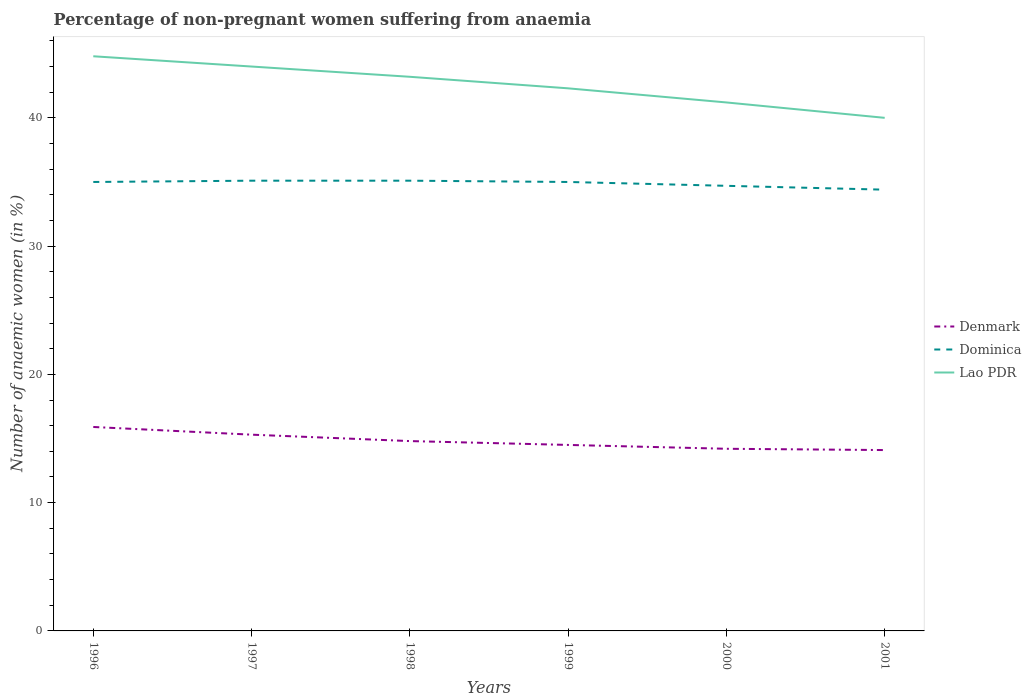Does the line corresponding to Denmark intersect with the line corresponding to Lao PDR?
Provide a succinct answer. No. What is the total percentage of non-pregnant women suffering from anaemia in Dominica in the graph?
Your response must be concise. 0.6. What is the difference between the highest and the second highest percentage of non-pregnant women suffering from anaemia in Dominica?
Make the answer very short. 0.7. How many lines are there?
Provide a short and direct response. 3. How many years are there in the graph?
Keep it short and to the point. 6. What is the difference between two consecutive major ticks on the Y-axis?
Offer a terse response. 10. Does the graph contain grids?
Make the answer very short. No. How many legend labels are there?
Give a very brief answer. 3. How are the legend labels stacked?
Keep it short and to the point. Vertical. What is the title of the graph?
Your answer should be compact. Percentage of non-pregnant women suffering from anaemia. Does "Germany" appear as one of the legend labels in the graph?
Keep it short and to the point. No. What is the label or title of the X-axis?
Provide a short and direct response. Years. What is the label or title of the Y-axis?
Your answer should be very brief. Number of anaemic women (in %). What is the Number of anaemic women (in %) in Lao PDR in 1996?
Offer a very short reply. 44.8. What is the Number of anaemic women (in %) in Denmark in 1997?
Provide a short and direct response. 15.3. What is the Number of anaemic women (in %) in Dominica in 1997?
Your answer should be compact. 35.1. What is the Number of anaemic women (in %) of Lao PDR in 1997?
Provide a succinct answer. 44. What is the Number of anaemic women (in %) in Dominica in 1998?
Offer a terse response. 35.1. What is the Number of anaemic women (in %) in Lao PDR in 1998?
Ensure brevity in your answer.  43.2. What is the Number of anaemic women (in %) in Denmark in 1999?
Your response must be concise. 14.5. What is the Number of anaemic women (in %) in Lao PDR in 1999?
Offer a very short reply. 42.3. What is the Number of anaemic women (in %) of Dominica in 2000?
Ensure brevity in your answer.  34.7. What is the Number of anaemic women (in %) in Lao PDR in 2000?
Provide a succinct answer. 41.2. What is the Number of anaemic women (in %) in Denmark in 2001?
Your answer should be compact. 14.1. What is the Number of anaemic women (in %) in Dominica in 2001?
Provide a short and direct response. 34.4. Across all years, what is the maximum Number of anaemic women (in %) in Dominica?
Provide a short and direct response. 35.1. Across all years, what is the maximum Number of anaemic women (in %) of Lao PDR?
Offer a terse response. 44.8. Across all years, what is the minimum Number of anaemic women (in %) of Dominica?
Offer a terse response. 34.4. Across all years, what is the minimum Number of anaemic women (in %) of Lao PDR?
Your answer should be compact. 40. What is the total Number of anaemic women (in %) of Denmark in the graph?
Provide a succinct answer. 88.8. What is the total Number of anaemic women (in %) of Dominica in the graph?
Your answer should be compact. 209.3. What is the total Number of anaemic women (in %) of Lao PDR in the graph?
Offer a very short reply. 255.5. What is the difference between the Number of anaemic women (in %) of Denmark in 1996 and that in 1998?
Give a very brief answer. 1.1. What is the difference between the Number of anaemic women (in %) of Dominica in 1996 and that in 1998?
Offer a very short reply. -0.1. What is the difference between the Number of anaemic women (in %) in Lao PDR in 1996 and that in 1998?
Offer a very short reply. 1.6. What is the difference between the Number of anaemic women (in %) in Denmark in 1996 and that in 1999?
Keep it short and to the point. 1.4. What is the difference between the Number of anaemic women (in %) in Dominica in 1996 and that in 1999?
Make the answer very short. 0. What is the difference between the Number of anaemic women (in %) in Dominica in 1996 and that in 2000?
Ensure brevity in your answer.  0.3. What is the difference between the Number of anaemic women (in %) of Lao PDR in 1996 and that in 2000?
Your response must be concise. 3.6. What is the difference between the Number of anaemic women (in %) of Denmark in 1996 and that in 2001?
Your response must be concise. 1.8. What is the difference between the Number of anaemic women (in %) of Lao PDR in 1996 and that in 2001?
Offer a terse response. 4.8. What is the difference between the Number of anaemic women (in %) in Denmark in 1997 and that in 1999?
Make the answer very short. 0.8. What is the difference between the Number of anaemic women (in %) in Denmark in 1997 and that in 2000?
Provide a succinct answer. 1.1. What is the difference between the Number of anaemic women (in %) of Dominica in 1997 and that in 2000?
Your answer should be very brief. 0.4. What is the difference between the Number of anaemic women (in %) in Lao PDR in 1997 and that in 2000?
Offer a terse response. 2.8. What is the difference between the Number of anaemic women (in %) of Lao PDR in 1997 and that in 2001?
Provide a short and direct response. 4. What is the difference between the Number of anaemic women (in %) in Denmark in 1998 and that in 1999?
Provide a succinct answer. 0.3. What is the difference between the Number of anaemic women (in %) in Dominica in 1998 and that in 2000?
Make the answer very short. 0.4. What is the difference between the Number of anaemic women (in %) of Lao PDR in 1998 and that in 2000?
Give a very brief answer. 2. What is the difference between the Number of anaemic women (in %) of Denmark in 1998 and that in 2001?
Offer a terse response. 0.7. What is the difference between the Number of anaemic women (in %) in Dominica in 1998 and that in 2001?
Make the answer very short. 0.7. What is the difference between the Number of anaemic women (in %) of Denmark in 1999 and that in 2000?
Keep it short and to the point. 0.3. What is the difference between the Number of anaemic women (in %) in Dominica in 1999 and that in 2000?
Give a very brief answer. 0.3. What is the difference between the Number of anaemic women (in %) of Denmark in 1999 and that in 2001?
Offer a terse response. 0.4. What is the difference between the Number of anaemic women (in %) of Dominica in 1999 and that in 2001?
Keep it short and to the point. 0.6. What is the difference between the Number of anaemic women (in %) in Denmark in 1996 and the Number of anaemic women (in %) in Dominica in 1997?
Make the answer very short. -19.2. What is the difference between the Number of anaemic women (in %) in Denmark in 1996 and the Number of anaemic women (in %) in Lao PDR in 1997?
Ensure brevity in your answer.  -28.1. What is the difference between the Number of anaemic women (in %) in Dominica in 1996 and the Number of anaemic women (in %) in Lao PDR in 1997?
Your answer should be compact. -9. What is the difference between the Number of anaemic women (in %) in Denmark in 1996 and the Number of anaemic women (in %) in Dominica in 1998?
Your response must be concise. -19.2. What is the difference between the Number of anaemic women (in %) in Denmark in 1996 and the Number of anaemic women (in %) in Lao PDR in 1998?
Your response must be concise. -27.3. What is the difference between the Number of anaemic women (in %) in Denmark in 1996 and the Number of anaemic women (in %) in Dominica in 1999?
Give a very brief answer. -19.1. What is the difference between the Number of anaemic women (in %) in Denmark in 1996 and the Number of anaemic women (in %) in Lao PDR in 1999?
Provide a short and direct response. -26.4. What is the difference between the Number of anaemic women (in %) of Dominica in 1996 and the Number of anaemic women (in %) of Lao PDR in 1999?
Provide a short and direct response. -7.3. What is the difference between the Number of anaemic women (in %) in Denmark in 1996 and the Number of anaemic women (in %) in Dominica in 2000?
Your answer should be compact. -18.8. What is the difference between the Number of anaemic women (in %) in Denmark in 1996 and the Number of anaemic women (in %) in Lao PDR in 2000?
Keep it short and to the point. -25.3. What is the difference between the Number of anaemic women (in %) of Denmark in 1996 and the Number of anaemic women (in %) of Dominica in 2001?
Keep it short and to the point. -18.5. What is the difference between the Number of anaemic women (in %) of Denmark in 1996 and the Number of anaemic women (in %) of Lao PDR in 2001?
Your answer should be compact. -24.1. What is the difference between the Number of anaemic women (in %) in Denmark in 1997 and the Number of anaemic women (in %) in Dominica in 1998?
Keep it short and to the point. -19.8. What is the difference between the Number of anaemic women (in %) of Denmark in 1997 and the Number of anaemic women (in %) of Lao PDR in 1998?
Keep it short and to the point. -27.9. What is the difference between the Number of anaemic women (in %) in Dominica in 1997 and the Number of anaemic women (in %) in Lao PDR in 1998?
Make the answer very short. -8.1. What is the difference between the Number of anaemic women (in %) in Denmark in 1997 and the Number of anaemic women (in %) in Dominica in 1999?
Provide a succinct answer. -19.7. What is the difference between the Number of anaemic women (in %) of Denmark in 1997 and the Number of anaemic women (in %) of Dominica in 2000?
Provide a short and direct response. -19.4. What is the difference between the Number of anaemic women (in %) in Denmark in 1997 and the Number of anaemic women (in %) in Lao PDR in 2000?
Offer a terse response. -25.9. What is the difference between the Number of anaemic women (in %) in Denmark in 1997 and the Number of anaemic women (in %) in Dominica in 2001?
Offer a very short reply. -19.1. What is the difference between the Number of anaemic women (in %) in Denmark in 1997 and the Number of anaemic women (in %) in Lao PDR in 2001?
Your answer should be very brief. -24.7. What is the difference between the Number of anaemic women (in %) in Denmark in 1998 and the Number of anaemic women (in %) in Dominica in 1999?
Offer a terse response. -20.2. What is the difference between the Number of anaemic women (in %) in Denmark in 1998 and the Number of anaemic women (in %) in Lao PDR in 1999?
Ensure brevity in your answer.  -27.5. What is the difference between the Number of anaemic women (in %) of Dominica in 1998 and the Number of anaemic women (in %) of Lao PDR in 1999?
Your answer should be compact. -7.2. What is the difference between the Number of anaemic women (in %) of Denmark in 1998 and the Number of anaemic women (in %) of Dominica in 2000?
Keep it short and to the point. -19.9. What is the difference between the Number of anaemic women (in %) of Denmark in 1998 and the Number of anaemic women (in %) of Lao PDR in 2000?
Keep it short and to the point. -26.4. What is the difference between the Number of anaemic women (in %) of Dominica in 1998 and the Number of anaemic women (in %) of Lao PDR in 2000?
Your answer should be compact. -6.1. What is the difference between the Number of anaemic women (in %) in Denmark in 1998 and the Number of anaemic women (in %) in Dominica in 2001?
Offer a very short reply. -19.6. What is the difference between the Number of anaemic women (in %) in Denmark in 1998 and the Number of anaemic women (in %) in Lao PDR in 2001?
Offer a very short reply. -25.2. What is the difference between the Number of anaemic women (in %) of Denmark in 1999 and the Number of anaemic women (in %) of Dominica in 2000?
Offer a terse response. -20.2. What is the difference between the Number of anaemic women (in %) in Denmark in 1999 and the Number of anaemic women (in %) in Lao PDR in 2000?
Keep it short and to the point. -26.7. What is the difference between the Number of anaemic women (in %) in Dominica in 1999 and the Number of anaemic women (in %) in Lao PDR in 2000?
Provide a short and direct response. -6.2. What is the difference between the Number of anaemic women (in %) of Denmark in 1999 and the Number of anaemic women (in %) of Dominica in 2001?
Your answer should be very brief. -19.9. What is the difference between the Number of anaemic women (in %) in Denmark in 1999 and the Number of anaemic women (in %) in Lao PDR in 2001?
Give a very brief answer. -25.5. What is the difference between the Number of anaemic women (in %) of Denmark in 2000 and the Number of anaemic women (in %) of Dominica in 2001?
Give a very brief answer. -20.2. What is the difference between the Number of anaemic women (in %) in Denmark in 2000 and the Number of anaemic women (in %) in Lao PDR in 2001?
Ensure brevity in your answer.  -25.8. What is the average Number of anaemic women (in %) of Denmark per year?
Give a very brief answer. 14.8. What is the average Number of anaemic women (in %) in Dominica per year?
Offer a terse response. 34.88. What is the average Number of anaemic women (in %) of Lao PDR per year?
Your answer should be very brief. 42.58. In the year 1996, what is the difference between the Number of anaemic women (in %) in Denmark and Number of anaemic women (in %) in Dominica?
Your answer should be very brief. -19.1. In the year 1996, what is the difference between the Number of anaemic women (in %) in Denmark and Number of anaemic women (in %) in Lao PDR?
Provide a succinct answer. -28.9. In the year 1997, what is the difference between the Number of anaemic women (in %) in Denmark and Number of anaemic women (in %) in Dominica?
Your answer should be very brief. -19.8. In the year 1997, what is the difference between the Number of anaemic women (in %) of Denmark and Number of anaemic women (in %) of Lao PDR?
Keep it short and to the point. -28.7. In the year 1997, what is the difference between the Number of anaemic women (in %) in Dominica and Number of anaemic women (in %) in Lao PDR?
Give a very brief answer. -8.9. In the year 1998, what is the difference between the Number of anaemic women (in %) of Denmark and Number of anaemic women (in %) of Dominica?
Your response must be concise. -20.3. In the year 1998, what is the difference between the Number of anaemic women (in %) in Denmark and Number of anaemic women (in %) in Lao PDR?
Offer a terse response. -28.4. In the year 1998, what is the difference between the Number of anaemic women (in %) in Dominica and Number of anaemic women (in %) in Lao PDR?
Offer a very short reply. -8.1. In the year 1999, what is the difference between the Number of anaemic women (in %) in Denmark and Number of anaemic women (in %) in Dominica?
Keep it short and to the point. -20.5. In the year 1999, what is the difference between the Number of anaemic women (in %) of Denmark and Number of anaemic women (in %) of Lao PDR?
Give a very brief answer. -27.8. In the year 1999, what is the difference between the Number of anaemic women (in %) of Dominica and Number of anaemic women (in %) of Lao PDR?
Keep it short and to the point. -7.3. In the year 2000, what is the difference between the Number of anaemic women (in %) in Denmark and Number of anaemic women (in %) in Dominica?
Offer a terse response. -20.5. In the year 2000, what is the difference between the Number of anaemic women (in %) in Dominica and Number of anaemic women (in %) in Lao PDR?
Make the answer very short. -6.5. In the year 2001, what is the difference between the Number of anaemic women (in %) in Denmark and Number of anaemic women (in %) in Dominica?
Provide a short and direct response. -20.3. In the year 2001, what is the difference between the Number of anaemic women (in %) in Denmark and Number of anaemic women (in %) in Lao PDR?
Make the answer very short. -25.9. In the year 2001, what is the difference between the Number of anaemic women (in %) of Dominica and Number of anaemic women (in %) of Lao PDR?
Your answer should be compact. -5.6. What is the ratio of the Number of anaemic women (in %) in Denmark in 1996 to that in 1997?
Keep it short and to the point. 1.04. What is the ratio of the Number of anaemic women (in %) in Lao PDR in 1996 to that in 1997?
Provide a succinct answer. 1.02. What is the ratio of the Number of anaemic women (in %) of Denmark in 1996 to that in 1998?
Give a very brief answer. 1.07. What is the ratio of the Number of anaemic women (in %) in Lao PDR in 1996 to that in 1998?
Give a very brief answer. 1.04. What is the ratio of the Number of anaemic women (in %) in Denmark in 1996 to that in 1999?
Give a very brief answer. 1.1. What is the ratio of the Number of anaemic women (in %) of Lao PDR in 1996 to that in 1999?
Give a very brief answer. 1.06. What is the ratio of the Number of anaemic women (in %) in Denmark in 1996 to that in 2000?
Provide a short and direct response. 1.12. What is the ratio of the Number of anaemic women (in %) of Dominica in 1996 to that in 2000?
Provide a succinct answer. 1.01. What is the ratio of the Number of anaemic women (in %) in Lao PDR in 1996 to that in 2000?
Provide a succinct answer. 1.09. What is the ratio of the Number of anaemic women (in %) in Denmark in 1996 to that in 2001?
Your response must be concise. 1.13. What is the ratio of the Number of anaemic women (in %) in Dominica in 1996 to that in 2001?
Provide a succinct answer. 1.02. What is the ratio of the Number of anaemic women (in %) in Lao PDR in 1996 to that in 2001?
Give a very brief answer. 1.12. What is the ratio of the Number of anaemic women (in %) in Denmark in 1997 to that in 1998?
Offer a very short reply. 1.03. What is the ratio of the Number of anaemic women (in %) in Dominica in 1997 to that in 1998?
Provide a short and direct response. 1. What is the ratio of the Number of anaemic women (in %) in Lao PDR in 1997 to that in 1998?
Make the answer very short. 1.02. What is the ratio of the Number of anaemic women (in %) of Denmark in 1997 to that in 1999?
Offer a very short reply. 1.06. What is the ratio of the Number of anaemic women (in %) in Lao PDR in 1997 to that in 1999?
Give a very brief answer. 1.04. What is the ratio of the Number of anaemic women (in %) in Denmark in 1997 to that in 2000?
Give a very brief answer. 1.08. What is the ratio of the Number of anaemic women (in %) in Dominica in 1997 to that in 2000?
Ensure brevity in your answer.  1.01. What is the ratio of the Number of anaemic women (in %) in Lao PDR in 1997 to that in 2000?
Provide a succinct answer. 1.07. What is the ratio of the Number of anaemic women (in %) in Denmark in 1997 to that in 2001?
Give a very brief answer. 1.09. What is the ratio of the Number of anaemic women (in %) in Dominica in 1997 to that in 2001?
Provide a succinct answer. 1.02. What is the ratio of the Number of anaemic women (in %) of Lao PDR in 1997 to that in 2001?
Provide a succinct answer. 1.1. What is the ratio of the Number of anaemic women (in %) in Denmark in 1998 to that in 1999?
Provide a short and direct response. 1.02. What is the ratio of the Number of anaemic women (in %) of Dominica in 1998 to that in 1999?
Give a very brief answer. 1. What is the ratio of the Number of anaemic women (in %) of Lao PDR in 1998 to that in 1999?
Your response must be concise. 1.02. What is the ratio of the Number of anaemic women (in %) in Denmark in 1998 to that in 2000?
Your response must be concise. 1.04. What is the ratio of the Number of anaemic women (in %) in Dominica in 1998 to that in 2000?
Provide a short and direct response. 1.01. What is the ratio of the Number of anaemic women (in %) of Lao PDR in 1998 to that in 2000?
Keep it short and to the point. 1.05. What is the ratio of the Number of anaemic women (in %) in Denmark in 1998 to that in 2001?
Provide a succinct answer. 1.05. What is the ratio of the Number of anaemic women (in %) of Dominica in 1998 to that in 2001?
Provide a succinct answer. 1.02. What is the ratio of the Number of anaemic women (in %) in Lao PDR in 1998 to that in 2001?
Your answer should be very brief. 1.08. What is the ratio of the Number of anaemic women (in %) in Denmark in 1999 to that in 2000?
Your answer should be very brief. 1.02. What is the ratio of the Number of anaemic women (in %) in Dominica in 1999 to that in 2000?
Your response must be concise. 1.01. What is the ratio of the Number of anaemic women (in %) of Lao PDR in 1999 to that in 2000?
Give a very brief answer. 1.03. What is the ratio of the Number of anaemic women (in %) of Denmark in 1999 to that in 2001?
Provide a succinct answer. 1.03. What is the ratio of the Number of anaemic women (in %) of Dominica in 1999 to that in 2001?
Offer a terse response. 1.02. What is the ratio of the Number of anaemic women (in %) in Lao PDR in 1999 to that in 2001?
Ensure brevity in your answer.  1.06. What is the ratio of the Number of anaemic women (in %) of Denmark in 2000 to that in 2001?
Your response must be concise. 1.01. What is the ratio of the Number of anaemic women (in %) in Dominica in 2000 to that in 2001?
Offer a terse response. 1.01. What is the ratio of the Number of anaemic women (in %) in Lao PDR in 2000 to that in 2001?
Provide a succinct answer. 1.03. What is the difference between the highest and the second highest Number of anaemic women (in %) of Lao PDR?
Your answer should be compact. 0.8. What is the difference between the highest and the lowest Number of anaemic women (in %) of Denmark?
Your response must be concise. 1.8. What is the difference between the highest and the lowest Number of anaemic women (in %) of Lao PDR?
Ensure brevity in your answer.  4.8. 